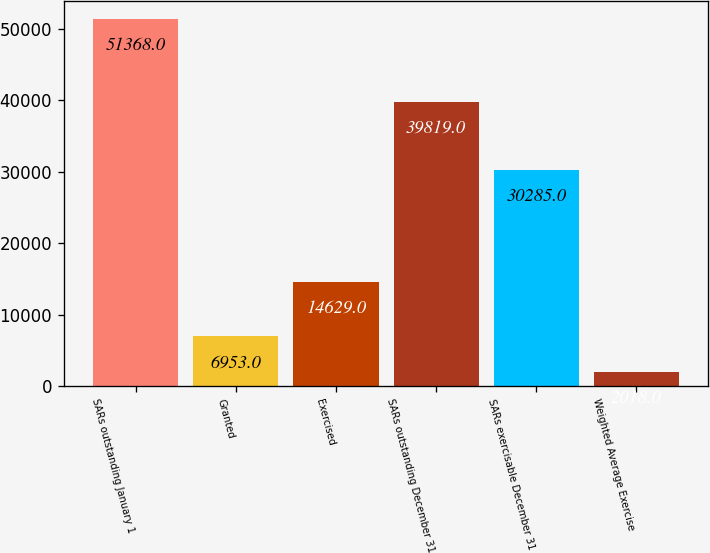<chart> <loc_0><loc_0><loc_500><loc_500><bar_chart><fcel>SARs outstanding January 1<fcel>Granted<fcel>Exercised<fcel>SARs outstanding December 31<fcel>SARs exercisable December 31<fcel>Weighted Average Exercise<nl><fcel>51368<fcel>6953<fcel>14629<fcel>39819<fcel>30285<fcel>2018<nl></chart> 